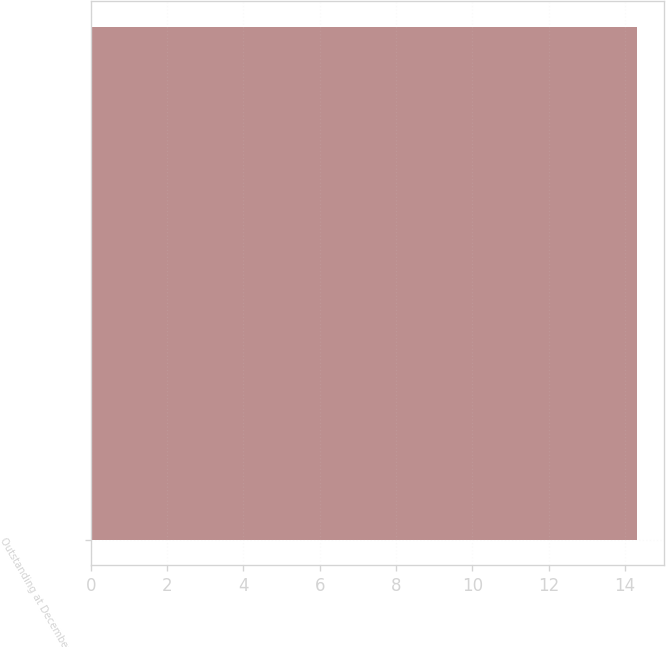Convert chart to OTSL. <chart><loc_0><loc_0><loc_500><loc_500><bar_chart><fcel>Outstanding at December 31<nl><fcel>14.31<nl></chart> 